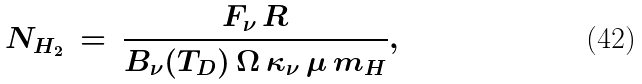<formula> <loc_0><loc_0><loc_500><loc_500>N _ { H _ { 2 } } \, = \, \frac { F _ { \nu } \, R } { B _ { \nu } ( T _ { D } ) \, \Omega \, \kappa _ { \nu } \, \mu \, m _ { H } } ,</formula> 